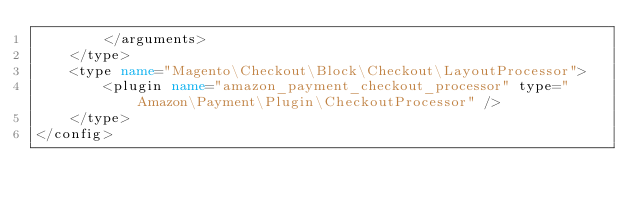Convert code to text. <code><loc_0><loc_0><loc_500><loc_500><_XML_>        </arguments>
    </type>
    <type name="Magento\Checkout\Block\Checkout\LayoutProcessor">
        <plugin name="amazon_payment_checkout_processor" type="Amazon\Payment\Plugin\CheckoutProcessor" />
    </type>
</config>
</code> 